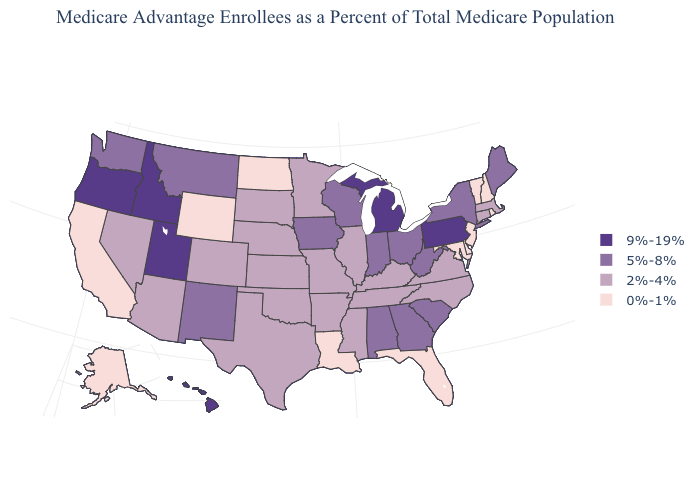Does Massachusetts have the highest value in the USA?
Write a very short answer. No. Name the states that have a value in the range 5%-8%?
Answer briefly. Alabama, Georgia, Iowa, Indiana, Maine, Montana, New Mexico, New York, Ohio, South Carolina, Washington, Wisconsin, West Virginia. Name the states that have a value in the range 9%-19%?
Be succinct. Hawaii, Idaho, Michigan, Oregon, Pennsylvania, Utah. Does Connecticut have a lower value than Nebraska?
Short answer required. No. What is the highest value in states that border Idaho?
Write a very short answer. 9%-19%. Name the states that have a value in the range 2%-4%?
Be succinct. Arkansas, Arizona, Colorado, Connecticut, Illinois, Kansas, Kentucky, Massachusetts, Minnesota, Missouri, Mississippi, North Carolina, Nebraska, Nevada, Oklahoma, South Dakota, Tennessee, Texas, Virginia. What is the value of Hawaii?
Write a very short answer. 9%-19%. What is the value of Wisconsin?
Write a very short answer. 5%-8%. What is the lowest value in the USA?
Short answer required. 0%-1%. Among the states that border Texas , does Arkansas have the highest value?
Keep it brief. No. What is the value of Idaho?
Quick response, please. 9%-19%. Does the first symbol in the legend represent the smallest category?
Write a very short answer. No. What is the lowest value in the West?
Give a very brief answer. 0%-1%. Name the states that have a value in the range 5%-8%?
Answer briefly. Alabama, Georgia, Iowa, Indiana, Maine, Montana, New Mexico, New York, Ohio, South Carolina, Washington, Wisconsin, West Virginia. Which states hav the highest value in the South?
Give a very brief answer. Alabama, Georgia, South Carolina, West Virginia. 